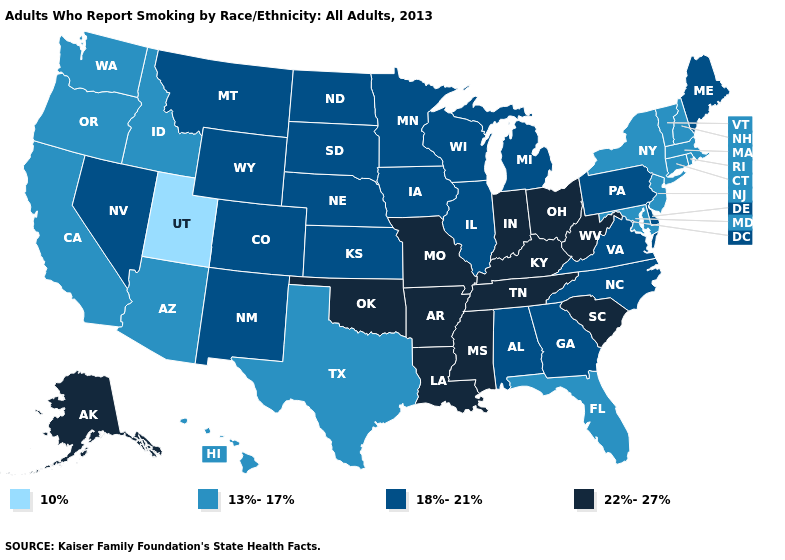What is the value of Nebraska?
Give a very brief answer. 18%-21%. Does Arizona have the same value as California?
Write a very short answer. Yes. What is the value of Hawaii?
Quick response, please. 13%-17%. Among the states that border New York , does Pennsylvania have the lowest value?
Quick response, please. No. Among the states that border Mississippi , does Alabama have the highest value?
Concise answer only. No. What is the value of Iowa?
Write a very short answer. 18%-21%. Name the states that have a value in the range 18%-21%?
Answer briefly. Alabama, Colorado, Delaware, Georgia, Illinois, Iowa, Kansas, Maine, Michigan, Minnesota, Montana, Nebraska, Nevada, New Mexico, North Carolina, North Dakota, Pennsylvania, South Dakota, Virginia, Wisconsin, Wyoming. Does Indiana have the highest value in the MidWest?
Give a very brief answer. Yes. Name the states that have a value in the range 10%?
Write a very short answer. Utah. Among the states that border Louisiana , which have the lowest value?
Short answer required. Texas. Name the states that have a value in the range 13%-17%?
Answer briefly. Arizona, California, Connecticut, Florida, Hawaii, Idaho, Maryland, Massachusetts, New Hampshire, New Jersey, New York, Oregon, Rhode Island, Texas, Vermont, Washington. Which states have the lowest value in the South?
Write a very short answer. Florida, Maryland, Texas. Name the states that have a value in the range 10%?
Quick response, please. Utah. What is the value of Michigan?
Keep it brief. 18%-21%. Does Vermont have the lowest value in the Northeast?
Short answer required. Yes. 